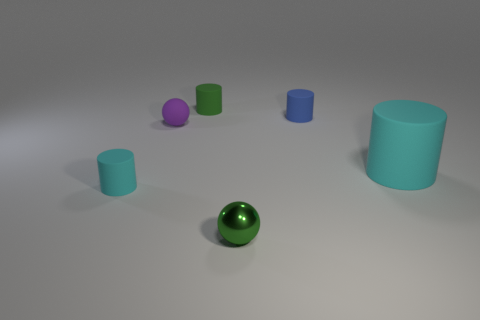Subtract all big cyan cylinders. How many cylinders are left? 3 Add 4 small balls. How many objects exist? 10 Subtract all green cylinders. How many cylinders are left? 3 Subtract all balls. How many objects are left? 4 Subtract all blue cylinders. How many cyan balls are left? 0 Add 5 small blue rubber cylinders. How many small blue rubber cylinders are left? 6 Add 1 small gray rubber cylinders. How many small gray rubber cylinders exist? 1 Subtract 1 blue cylinders. How many objects are left? 5 Subtract 2 balls. How many balls are left? 0 Subtract all purple cylinders. Subtract all gray spheres. How many cylinders are left? 4 